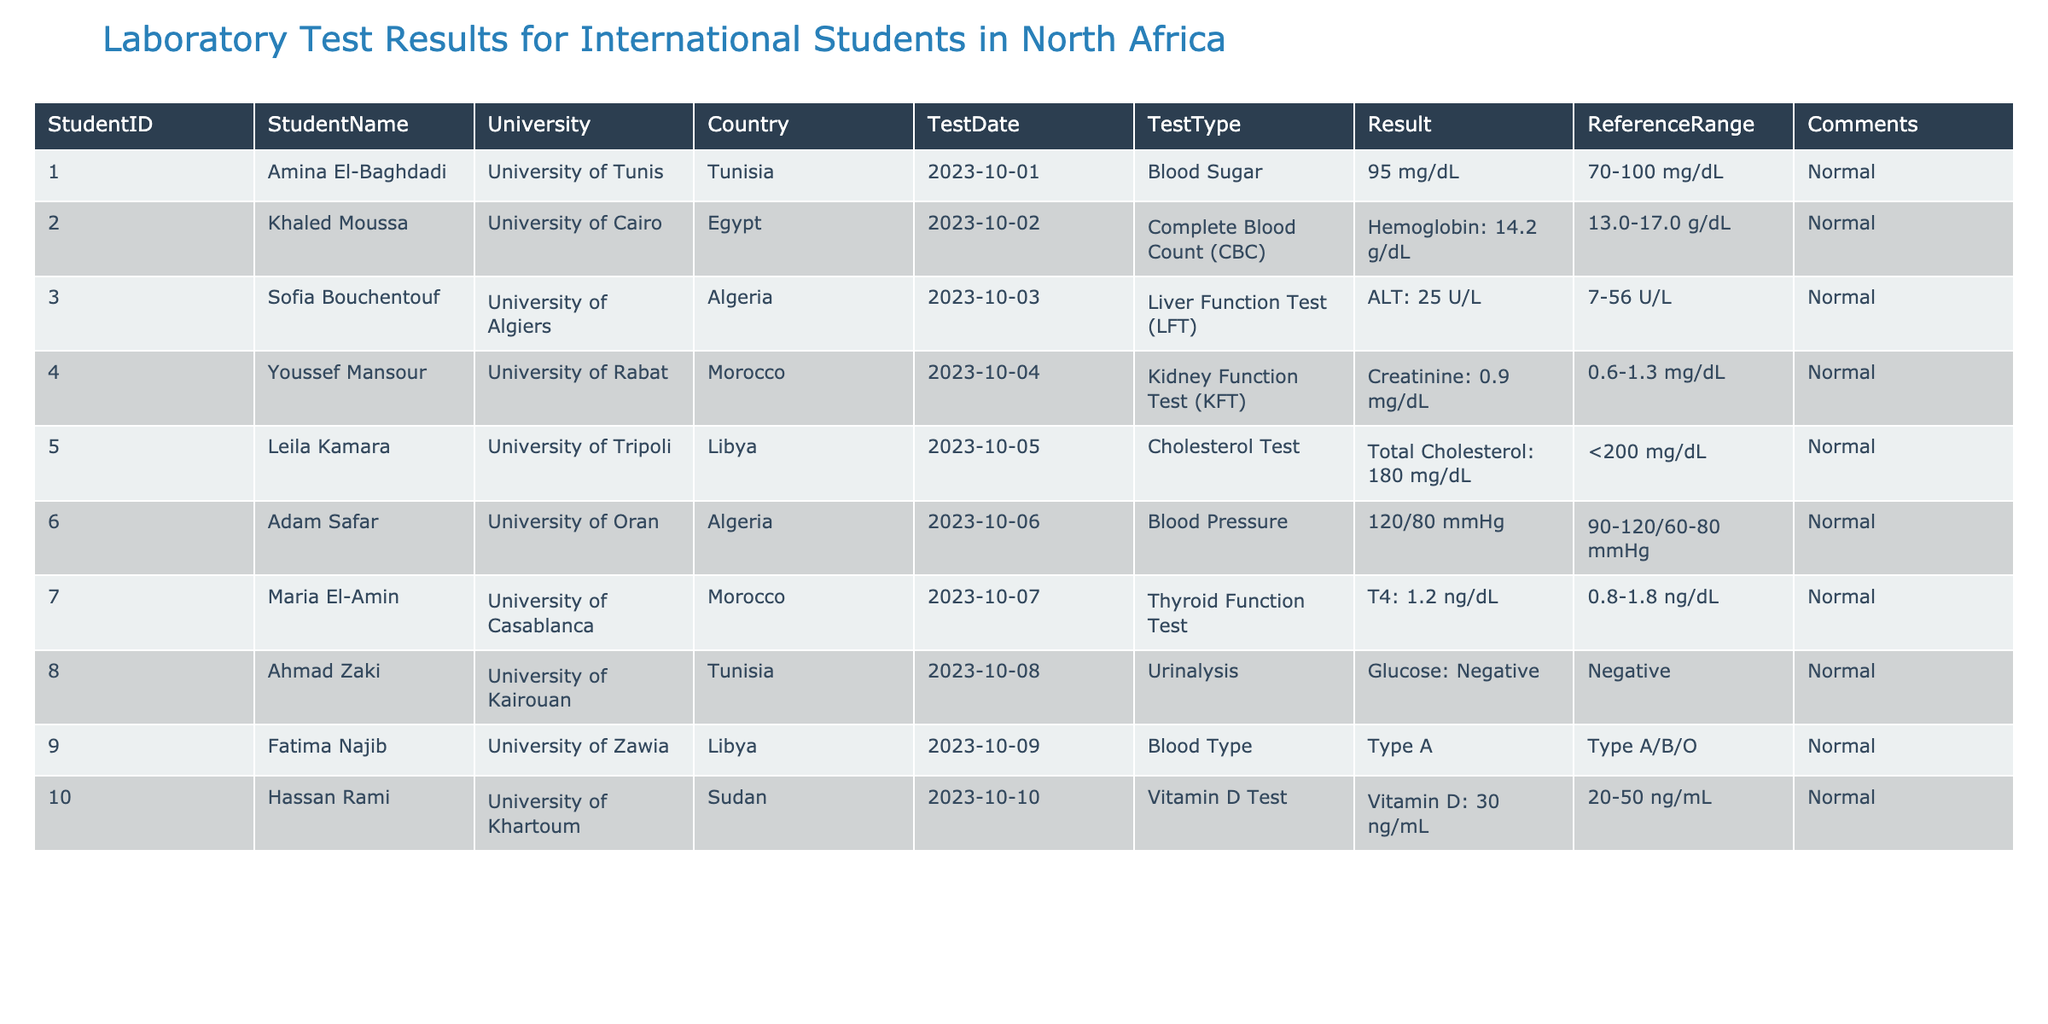What is the result of Amina El-Baghdadi's Blood Sugar test? Amina El-Baghdadi's Blood Sugar test result is listed in the table as 95 mg/dL.
Answer: 95 mg/dL Which student had a hemoglobin level of 14.2 g/dL? The table indicates that Khaled Moussa had a hemoglobin level of 14.2 g/dL under the Complete Blood Count (CBC) test.
Answer: Khaled Moussa Did any student have a cholesterol level above 200 mg/dL? By inspecting the cholesterol test results, Leila Kamara had a total cholesterol level of 180 mg/dL, which is below 200 mg/dL. Therefore, no student had a cholesterol level above 200 mg/dL.
Answer: No What was the average ALT value reported in the liver function tests? Only Sofia Bouchentouf's ALT value is listed at 25 U/L, so the average is 25 U/L since there are no other entries to average.
Answer: 25 U/L How many students had normal test results across all tests? All students listed in the table have comments indicating normal results. Therefore, counting all entries, we have 10 students with normal results across all tests.
Answer: 10 students Was Ahmad Zaki's Urinalysis result negative? The table shows that Ahmad Zaki's Urinalysis result for glucose was negative, confirming that his test result was indeed negative.
Answer: Yes Which test had the maximum reference range? Comparing the reference ranges, the Complete Blood Count (CBC) shows a range of 13.0-17.0 g/dL for hemoglobin, which is the widest compared to the others.
Answer: Hemoglobin in CBC What percentage of the students' test results were reported as normal? Since all students tested had normal results, the percentage can be calculated by taking the number of students with normal results (10) divided by the total number of students (10), which equals 100%.
Answer: 100% Which student's Vitamin D level is closest to the reference range maximum? Hassan Rami's Vitamin D level is reported as 30 ng/mL, just below the maximum of 50 ng/mL in the reference range, which makes it the closest to the maximum among the listed results.
Answer: Hassan Rami 